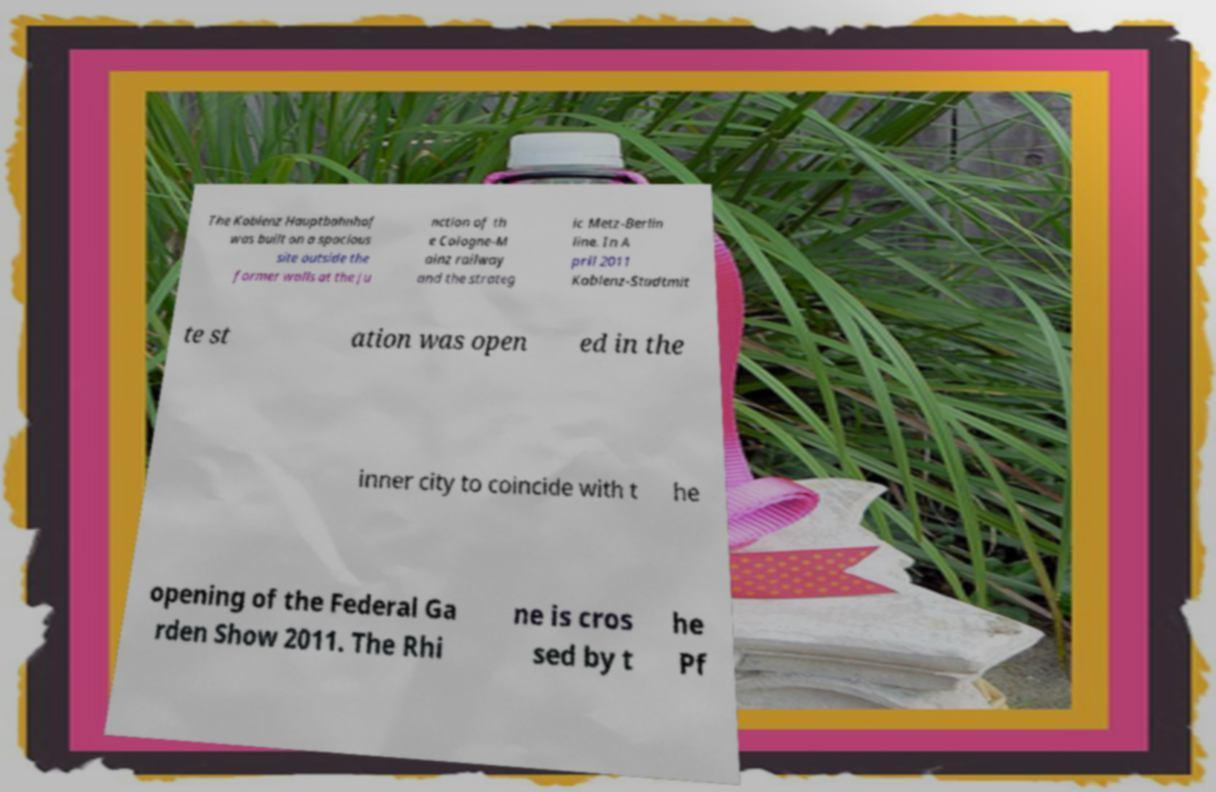I need the written content from this picture converted into text. Can you do that? The Koblenz Hauptbahnhof was built on a spacious site outside the former walls at the ju nction of th e Cologne-M ainz railway and the strateg ic Metz-Berlin line. In A pril 2011 Koblenz-Stadtmit te st ation was open ed in the inner city to coincide with t he opening of the Federal Ga rden Show 2011. The Rhi ne is cros sed by t he Pf 